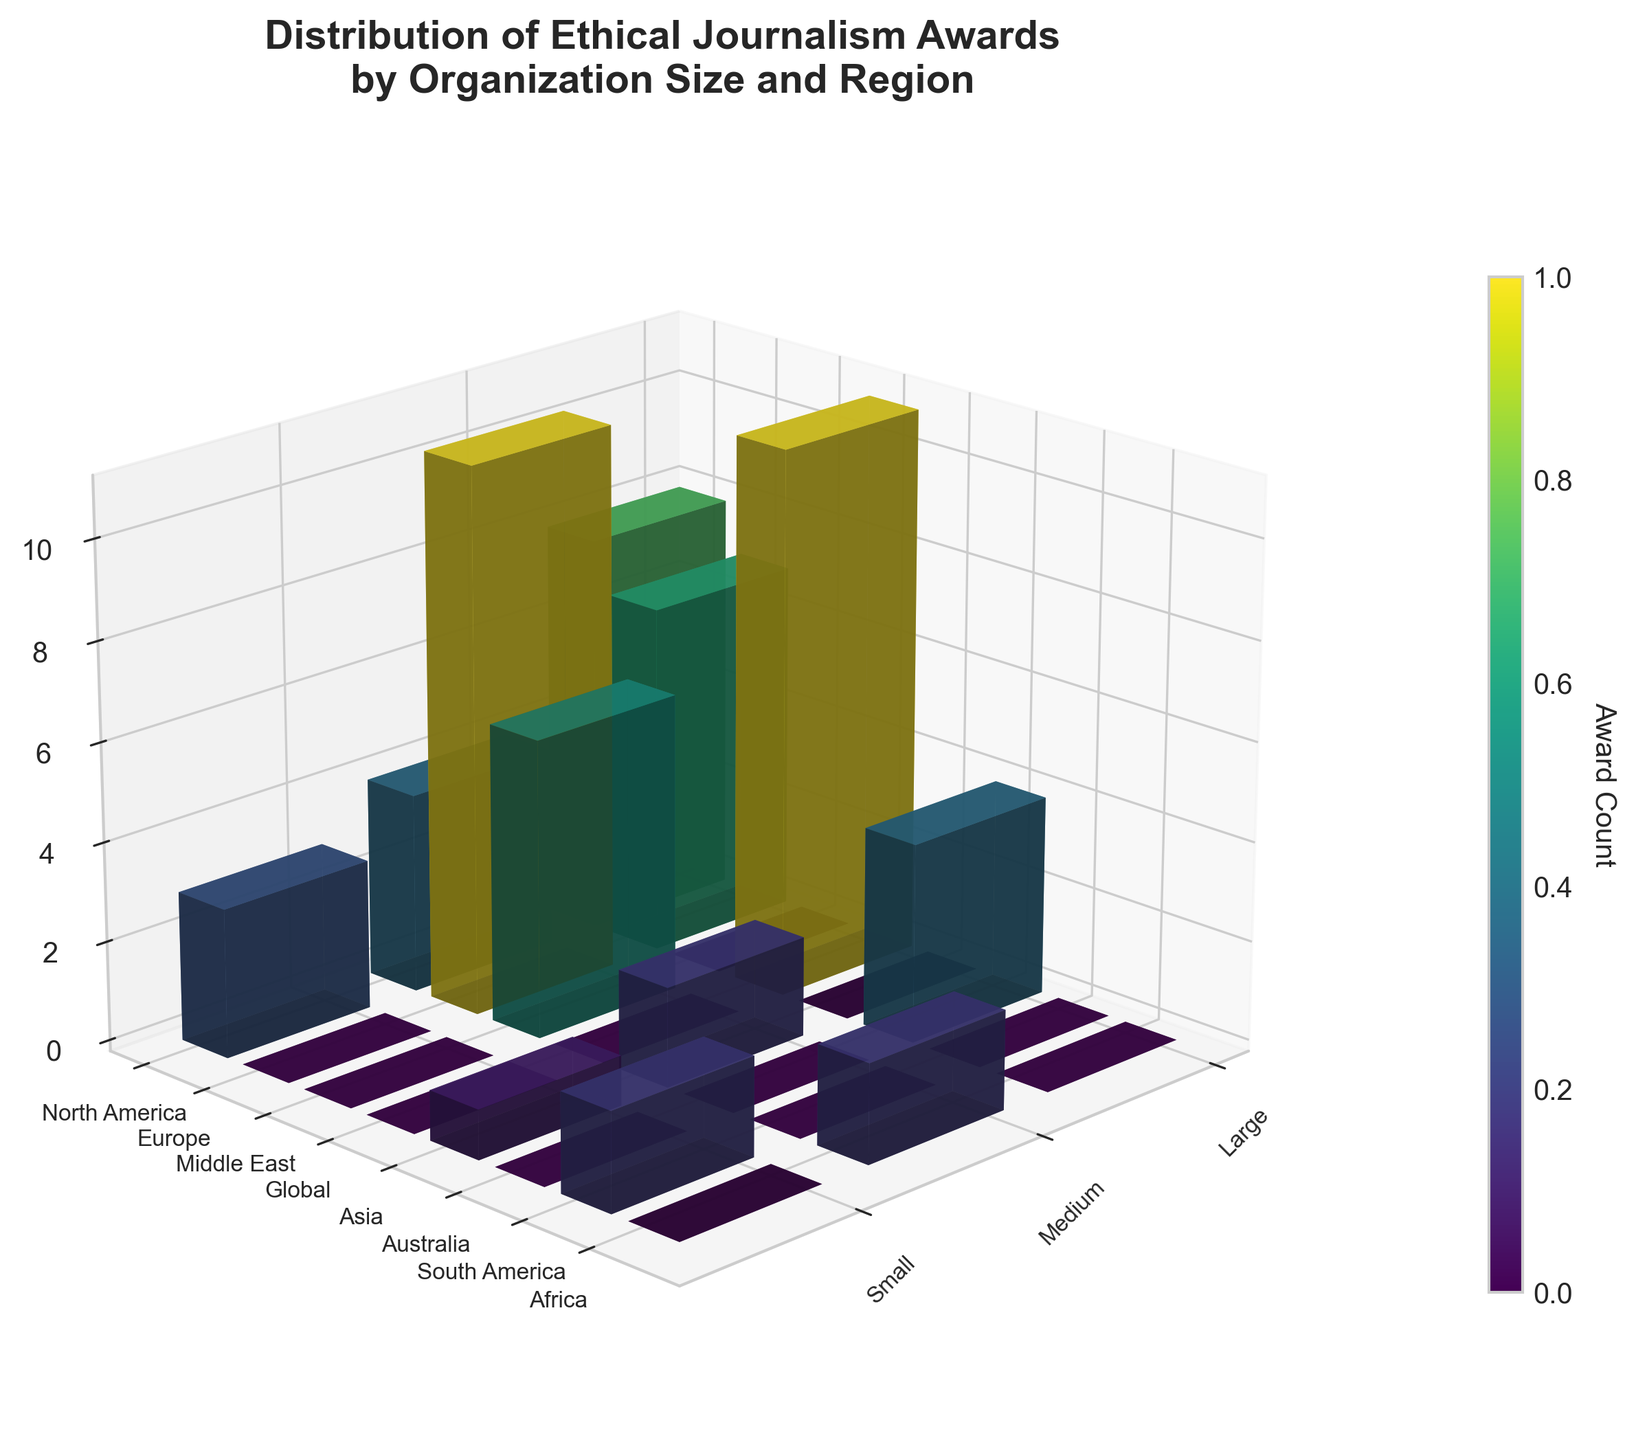What is the title of the figure? The title is displayed at the top of the figure in bold and larger font, it reads "Distribution of Ethical Journalism Awards by Organization Size and Region."
Answer: Distribution of Ethical Journalism Awards by Organization Size and Region How many different organization sizes are represented in the plot? The x-axis labels represent organization sizes and there are labels for "Large," "Medium," and "Small."
Answer: 3 Which region has the highest total number of awards? The y-axis labels represent regions, and the color bar indicates the award count with darker colors corresponding to higher values. By comparing the bars across different regions, North America has the highest total.
Answer: North America Which combination of organization size and region has the least awards? By examining the heights and colors of the bars, the combination of "Small" organizations in the "Asia" region has the shortest bar and the lightest color.
Answer: Small in Asia What is the total number of awards for Medium-sized organizations in Europe? Locate Medium on the x-axis and Europe on the y-axis. Identify the height of the bar at their intersection, which indicates the total awards.
Answer: 11 Compare the number of awards between Large organizations in North America and Large organizations in Europe. Which has more? Find the intersections: Large and North America and Large and Europe. The height of the bars tells us the number of awards. North America has more.
Answer: North America Which region has the most diverse sizes of organizations in terms of award counts? Diverse sizes imply different organization sizes having significant award counts. Regions with noticeable heights for small, medium, and large organizations indicate diversity. North America shows diversity.
Answer: North America How does the award count for Medium organizations in North America compare to Small organizations in South America? Identify their respective bars and compare the heights. Medium in North America has more awards.
Answer: Medium in North America What is the median total number of awards across all regions? Identify the total awards for each region from the bars on the y-axis, sort them, and find the middle value. Given a mix of values, find the central or average of the central two if an even number.
Answer: Approx. 7 Which organization size has the highest average number of awards across all regions? Calculate or estimate the average for each size by summing the bar heights and dividing by the number of regions. Large organizations average higher due to consistent tall bars.
Answer: Large 